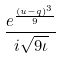<formula> <loc_0><loc_0><loc_500><loc_500>\frac { e ^ { \frac { ( u - q ) ^ { 3 } } { 9 } } } { i \sqrt { 9 \iota } }</formula> 